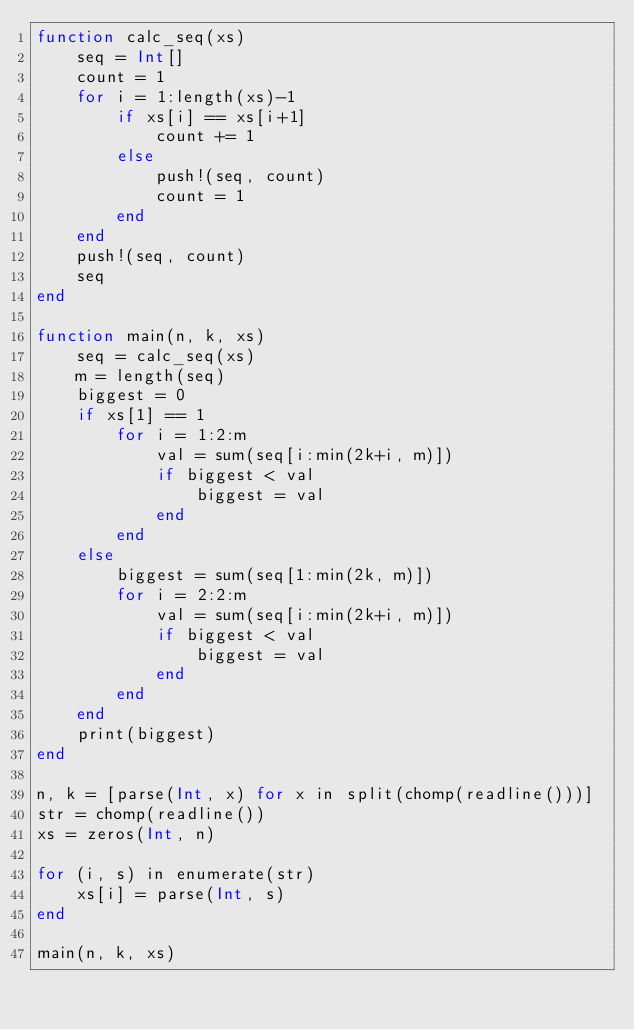<code> <loc_0><loc_0><loc_500><loc_500><_Julia_>function calc_seq(xs)
    seq = Int[]
    count = 1
    for i = 1:length(xs)-1
        if xs[i] == xs[i+1]
            count += 1
        else
            push!(seq, count)
            count = 1
        end
    end
    push!(seq, count)
    seq
end

function main(n, k, xs)
    seq = calc_seq(xs)
    m = length(seq)
    biggest = 0
    if xs[1] == 1
        for i = 1:2:m
            val = sum(seq[i:min(2k+i, m)])
            if biggest < val
                biggest = val
            end
        end
    else
        biggest = sum(seq[1:min(2k, m)])
        for i = 2:2:m
            val = sum(seq[i:min(2k+i, m)])
            if biggest < val
                biggest = val
            end
        end
    end
    print(biggest)
end

n, k = [parse(Int, x) for x in split(chomp(readline()))]
str = chomp(readline())
xs = zeros(Int, n)

for (i, s) in enumerate(str)
    xs[i] = parse(Int, s)
end

main(n, k, xs)</code> 